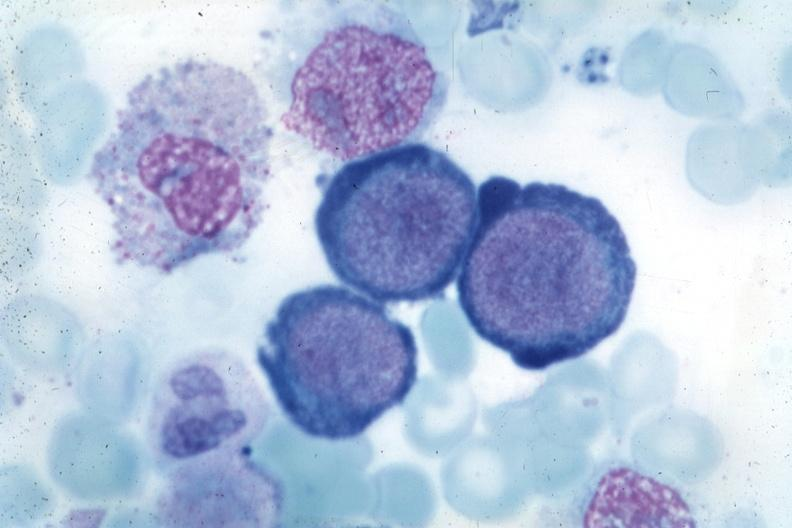what is present?
Answer the question using a single word or phrase. Megaloblasts pernicious anemia 